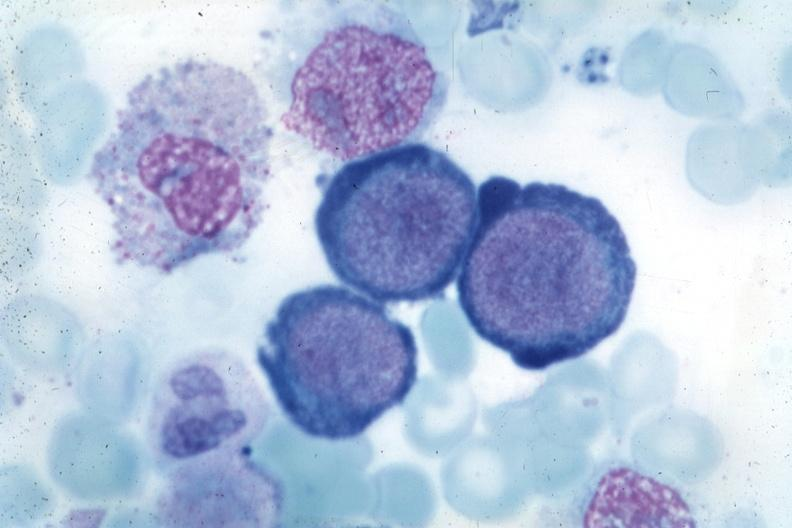what is present?
Answer the question using a single word or phrase. Megaloblasts pernicious anemia 